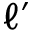Convert formula to latex. <formula><loc_0><loc_0><loc_500><loc_500>\ell ^ { \prime }</formula> 